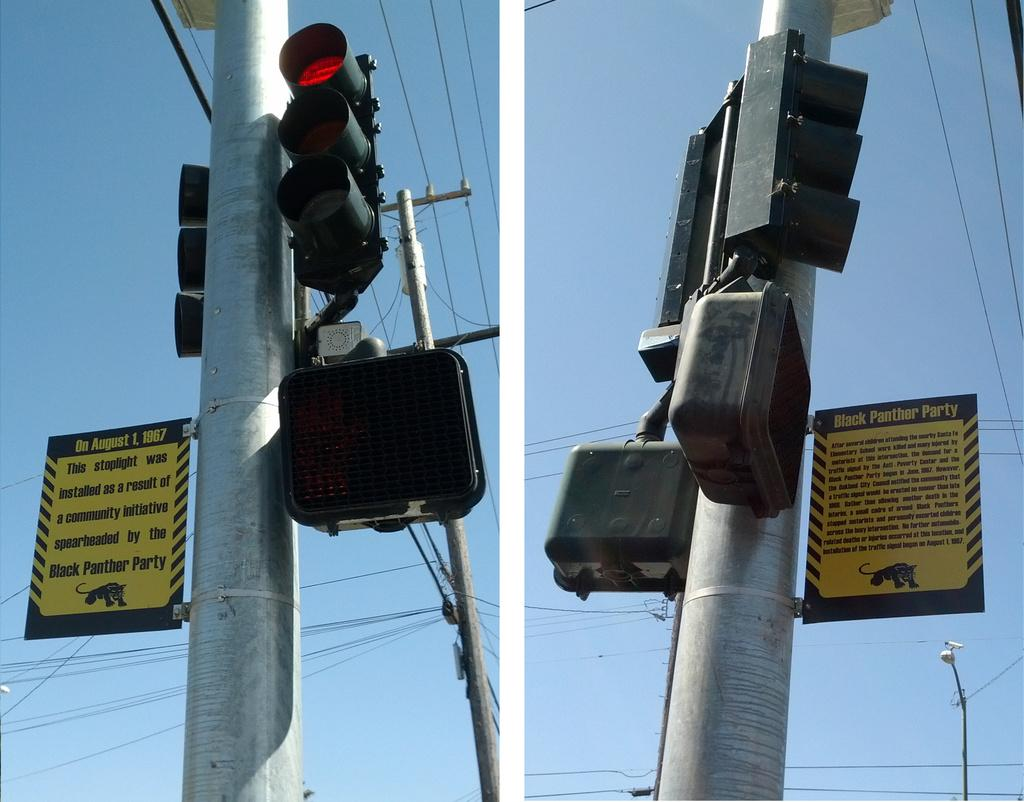<image>
Render a clear and concise summary of the photo. a sign that says 1967 on it that is on a light 